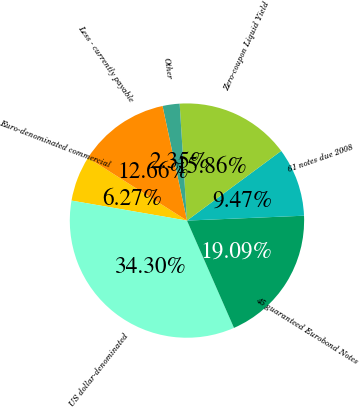Convert chart to OTSL. <chart><loc_0><loc_0><loc_500><loc_500><pie_chart><fcel>Euro-denominated commercial<fcel>US dollar-denominated<fcel>45 guaranteed Eurobond Notes<fcel>61 notes due 2008<fcel>Zero-coupon Liquid Yield<fcel>Other<fcel>Less - currently payable<nl><fcel>6.27%<fcel>34.3%<fcel>19.09%<fcel>9.47%<fcel>15.86%<fcel>2.35%<fcel>12.66%<nl></chart> 